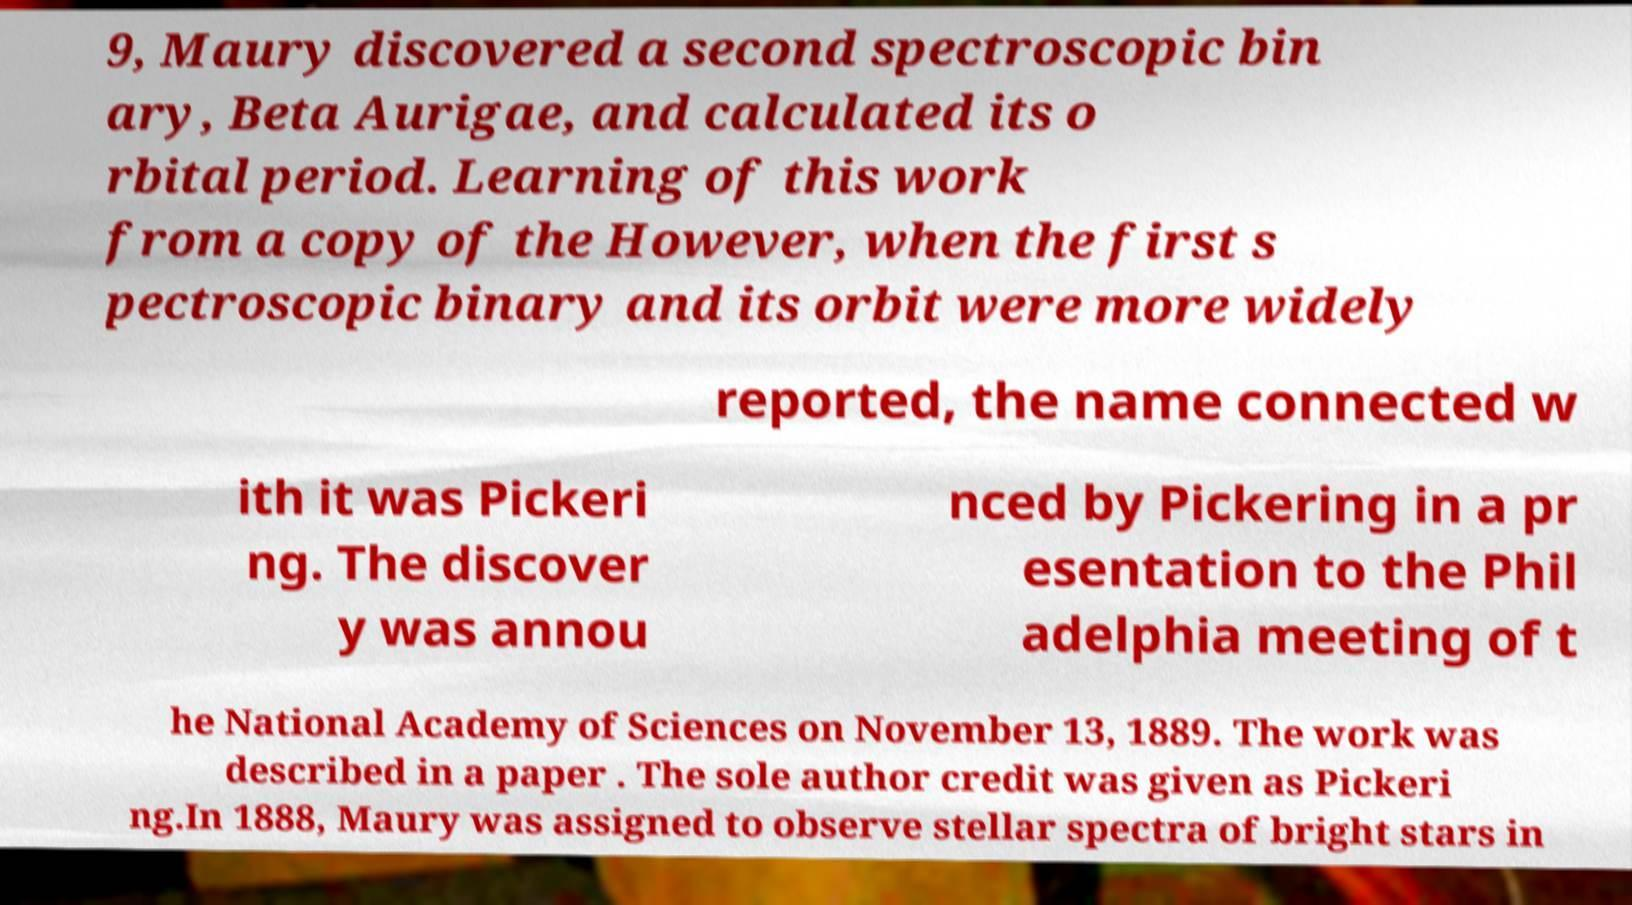There's text embedded in this image that I need extracted. Can you transcribe it verbatim? 9, Maury discovered a second spectroscopic bin ary, Beta Aurigae, and calculated its o rbital period. Learning of this work from a copy of the However, when the first s pectroscopic binary and its orbit were more widely reported, the name connected w ith it was Pickeri ng. The discover y was annou nced by Pickering in a pr esentation to the Phil adelphia meeting of t he National Academy of Sciences on November 13, 1889. The work was described in a paper . The sole author credit was given as Pickeri ng.In 1888, Maury was assigned to observe stellar spectra of bright stars in 